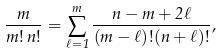<formula> <loc_0><loc_0><loc_500><loc_500>\frac { m } { m ! \, n ! } = \sum _ { \ell = 1 } ^ { m } \frac { n - m + 2 \ell } { ( m - \ell ) ! ( n + \ell ) ! } ,</formula> 